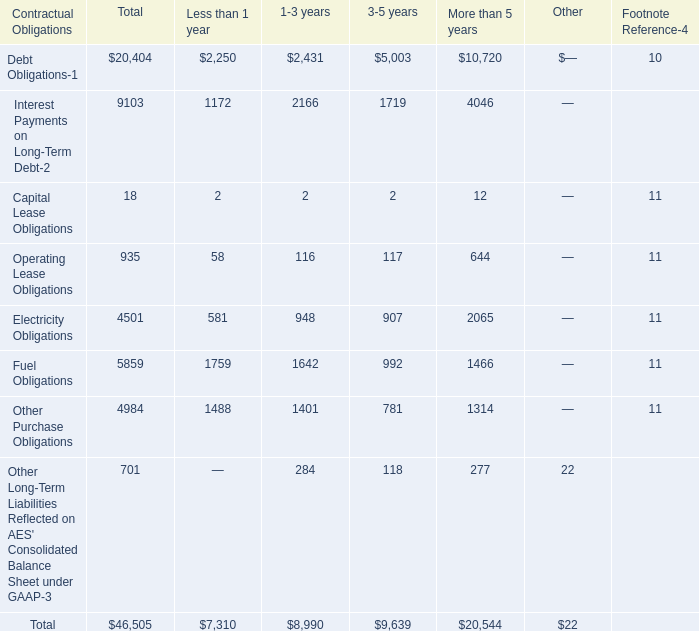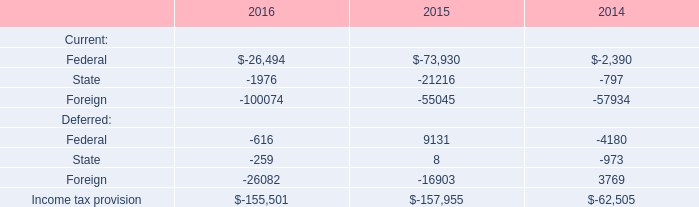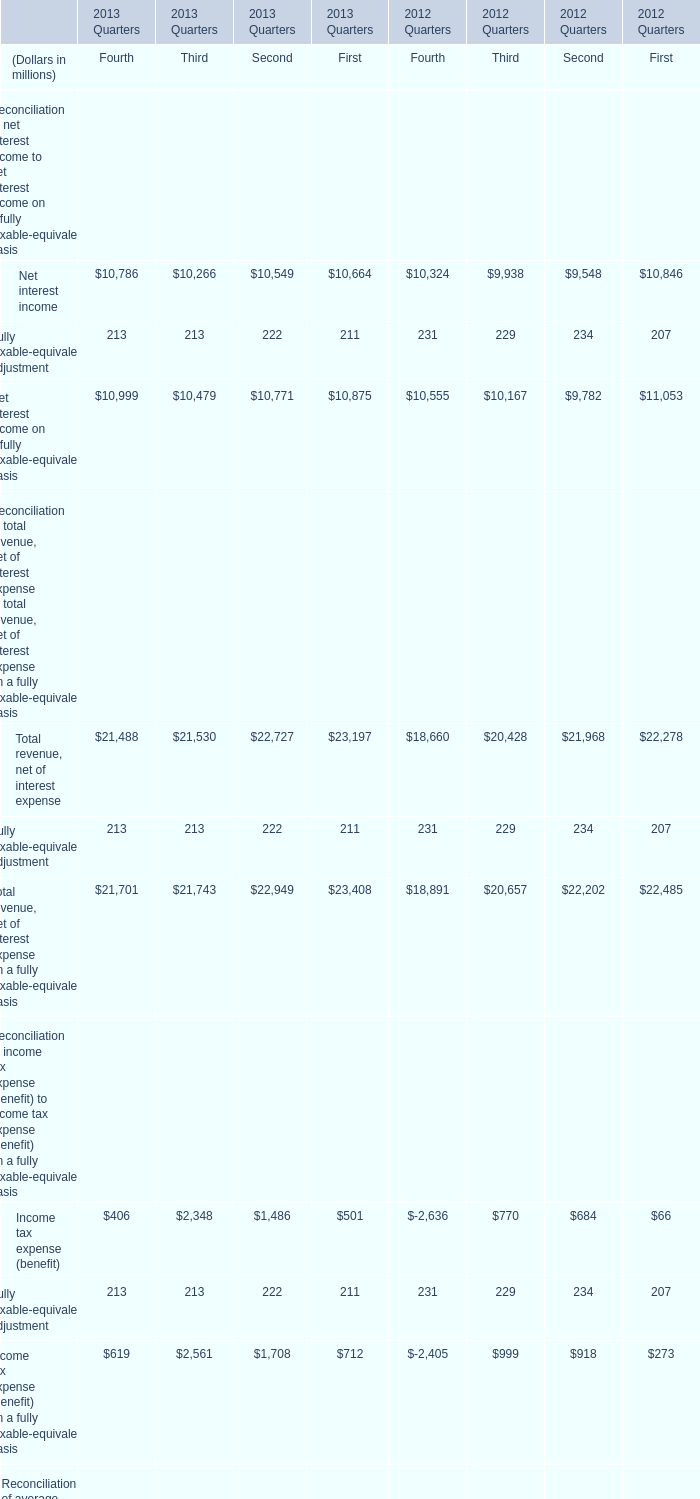What's the average of Net interest income and Fully taxable-equivalent adjustment in 2013? (in million) 
Computations: ((((((((10786 + 10266) + 10549) + 10664) + 213) + 213) + 222) + 211) / 2)
Answer: 21562.0. 